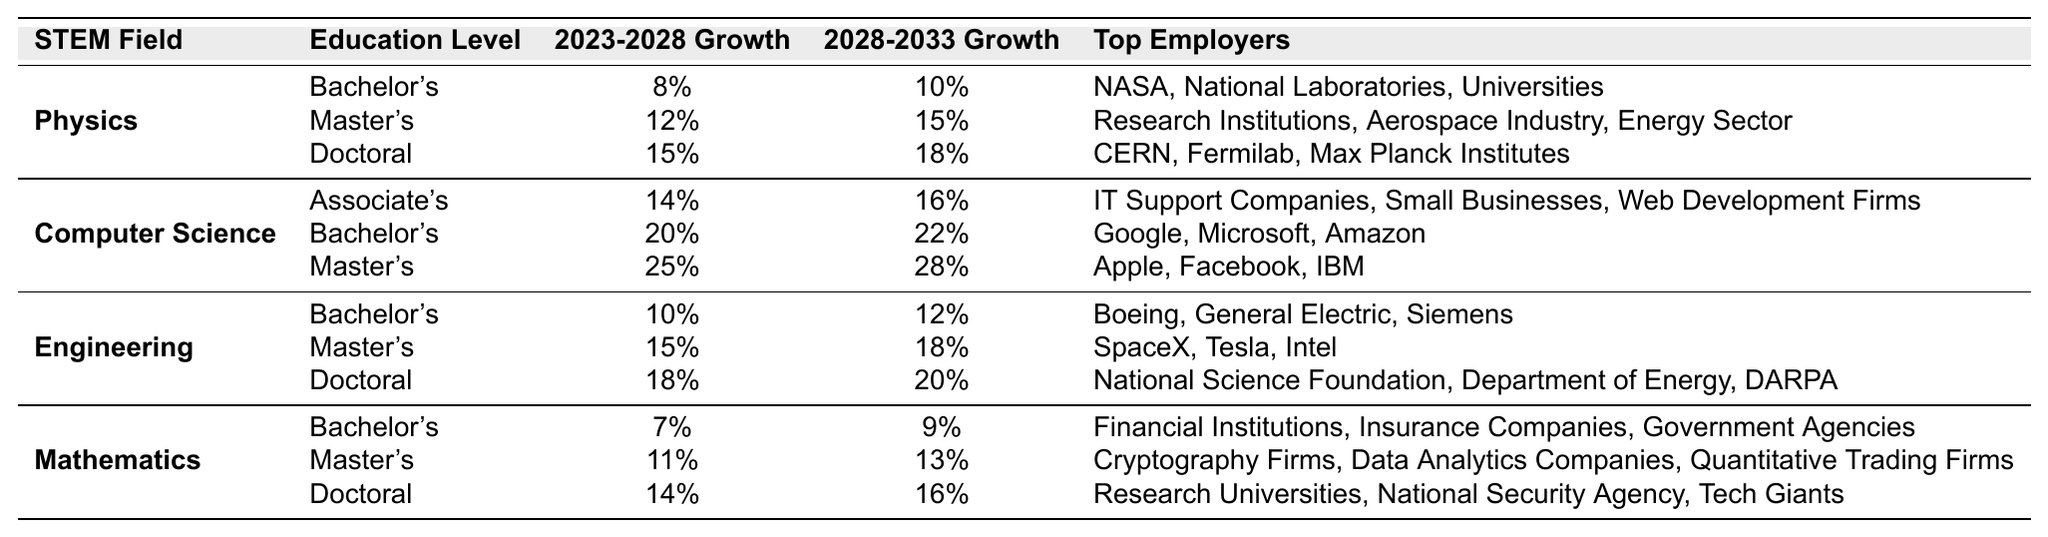What is the growth projection for Physics jobs with a Master's degree from 2023 to 2028? The table lists the growth projection for Physics jobs at the Master's degree level as 12% for the period from 2023 to 2028.
Answer: 12% Which field has the highest job growth projection for the Master's degree level between 2028-2033? In the table, Computer Science has the highest growth projection of 28% for Master's degree holders between 2028-2033, compared to 18% for Engineering and 15% for Physics.
Answer: Computer Science Is the growth rate for Mathematics with a Bachelor's degree higher than that for Engineering with the same degree from 2023 to 2028? According to the table, Mathematics has a growth rate of 7% for Bachelor's degree holders while Engineering has 10%. Since 10% is greater than 7%, the statement is false.
Answer: No What is the average growth rate for Doctoral degree holders across all fields from 2023 to 2028? The growth rates for Doctoral degree holders are 15% for Physics, 18% for Engineering, and 14% for Mathematics. To find the average, add them up (15 + 18 + 14 = 47) and divide by 3, which gives an average of 15.67%.
Answer: 15.67% Which field requires the highest education level to achieve the highest growth projection for the 2023-2028 period? For the 2023-2028 period, the highest growth projection is 25% in Computer Science, which requires a Master's degree. In Physics and Engineering, the highest growth projections (15% and 18%) come from Doctoral degrees. Thus, Computer Science requires a Master's degree for its highest projection, while others require Doctoral degrees for their highest projections.
Answer: Computer Science What is the difference in growth rate between Master's and Doctoral degree holders in Engineering for the 2028-2033 period? For Engineering, the growth projection for Master's degree holders is 18% while for Doctoral degree holders it is 20%. To find the difference, subtract the Master's rate from the Doctoral rate: 20% - 18% = 2%.
Answer: 2% Do top employers for Bachelor's degree holders in Physics include any government-related organizations? The top employers listed for Bachelor's degree holders in Physics are NASA, National Laboratories, and Universities. Since NASA and National Laboratories can be considered government-related, the answer is yes.
Answer: Yes Which field has a higher growth projection from 2028 to 2033, Physics with a Bachelor's degree or Engineering with a Master's degree? Physics with a Bachelor's degree has a growth projection of 10%, while Engineering with a Master's degree has a growth projection of 18%. Since 18% is greater than 10%, Engineering has a higher projection.
Answer: Engineering What is the top employer for Doctoral degree holders in Mathematics? The table lists Research Universities, National Security Agency, and Tech Giants as top employers for Doctoral degree holders in Mathematics. Therefore, one of the top employers is Research Universities.
Answer: Research Universities How much will job growth for jobs in Computer Science with a Bachelor's degree increase from 2023 to 2033? The growth for Bachelor's degree jobs in Computer Science is 20% from 2023 to 2028 and then increases to 22% between 2028 to 2033. To find the total increase, we look at the difference: 22% - 20% = 2%. Consequently, the total growth from 2023 to 2033 is 2%.
Answer: 2% 